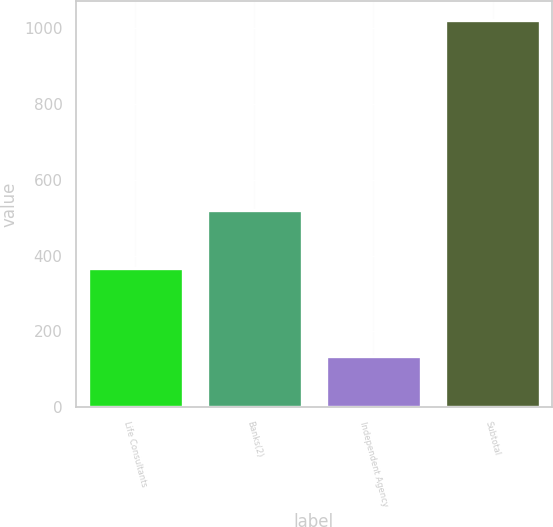Convert chart to OTSL. <chart><loc_0><loc_0><loc_500><loc_500><bar_chart><fcel>Life Consultants<fcel>Banks(2)<fcel>Independent Agency<fcel>Subtotal<nl><fcel>366<fcel>521<fcel>134<fcel>1021<nl></chart> 